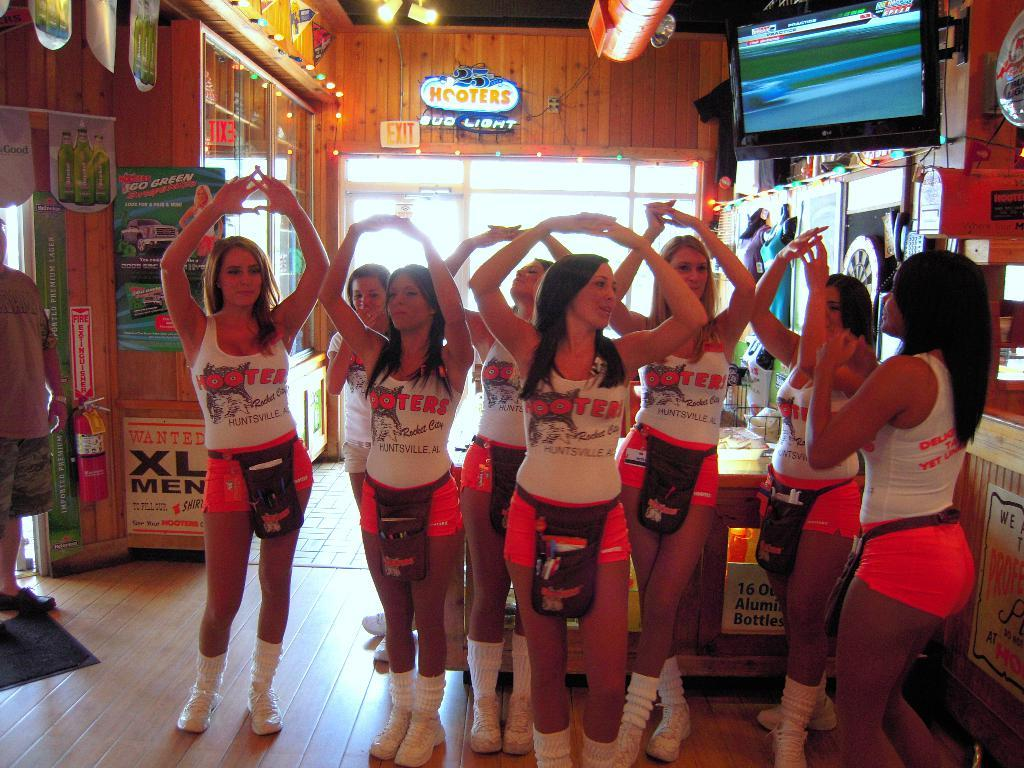<image>
Relay a brief, clear account of the picture shown. Some women in red and white standing in front of a sign for Hooters. 